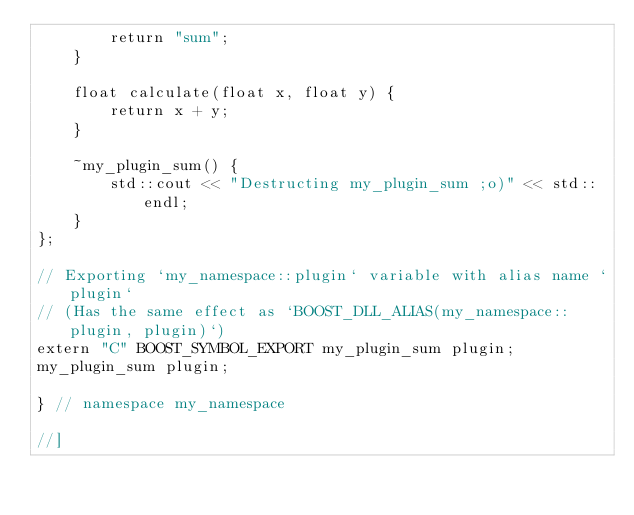<code> <loc_0><loc_0><loc_500><loc_500><_C++_>        return "sum";
    }

    float calculate(float x, float y) {
        return x + y;
    }
   
    ~my_plugin_sum() {
        std::cout << "Destructing my_plugin_sum ;o)" << std::endl;
    }
};

// Exporting `my_namespace::plugin` variable with alias name `plugin`
// (Has the same effect as `BOOST_DLL_ALIAS(my_namespace::plugin, plugin)`)
extern "C" BOOST_SYMBOL_EXPORT my_plugin_sum plugin;
my_plugin_sum plugin;

} // namespace my_namespace

//]
</code> 